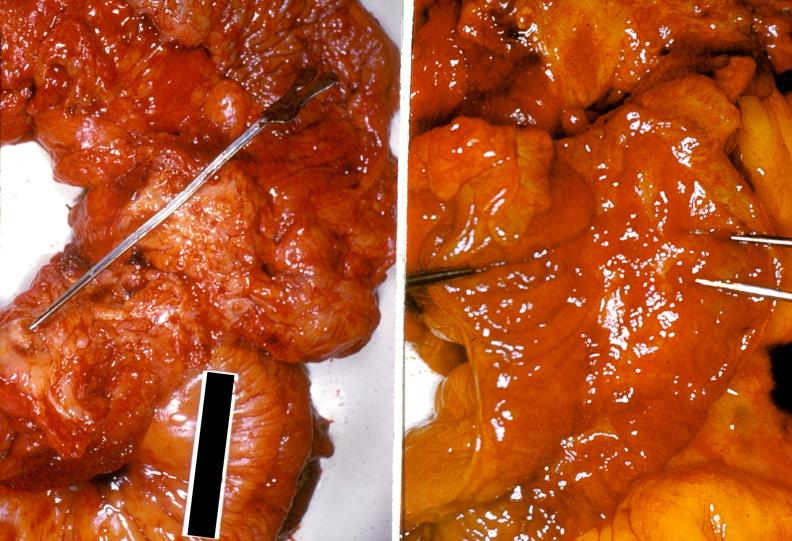does metastatic carcinoma prostate show ileum, ileitis due to chronic ulcerative colitis?
Answer the question using a single word or phrase. No 